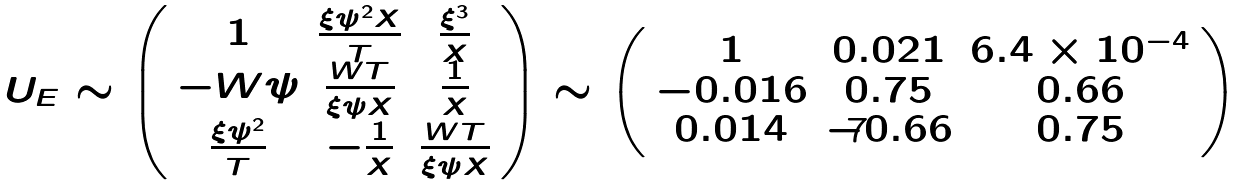<formula> <loc_0><loc_0><loc_500><loc_500>U _ { E } \sim \left ( \begin{array} { c c c } { 1 } & { { \frac { \xi \psi ^ { 2 } X } { T } } } & { { \frac { \xi ^ { 3 } } { X } } } \\ { - W \psi } & { { \frac { W T } { \xi \psi X } } } & { { \frac { 1 } { X } } } \\ { { \frac { \xi \psi ^ { 2 } } { T } } } & { { - \frac { 1 } { X } } } & { { \frac { W T } { \xi \psi X } } } \end{array} \right ) \sim \left ( \begin{array} { c c c } { 1 } & { 0 . 0 2 1 } & { { 6 . 4 \times 1 0 ^ { - 4 } } } \\ { - 0 . 0 1 6 } & { 0 . 7 5 } & { 0 . 6 6 } \\ { 0 . 0 1 4 } & { - 0 . 6 6 } & { 0 . 7 5 } \end{array} \right )</formula> 